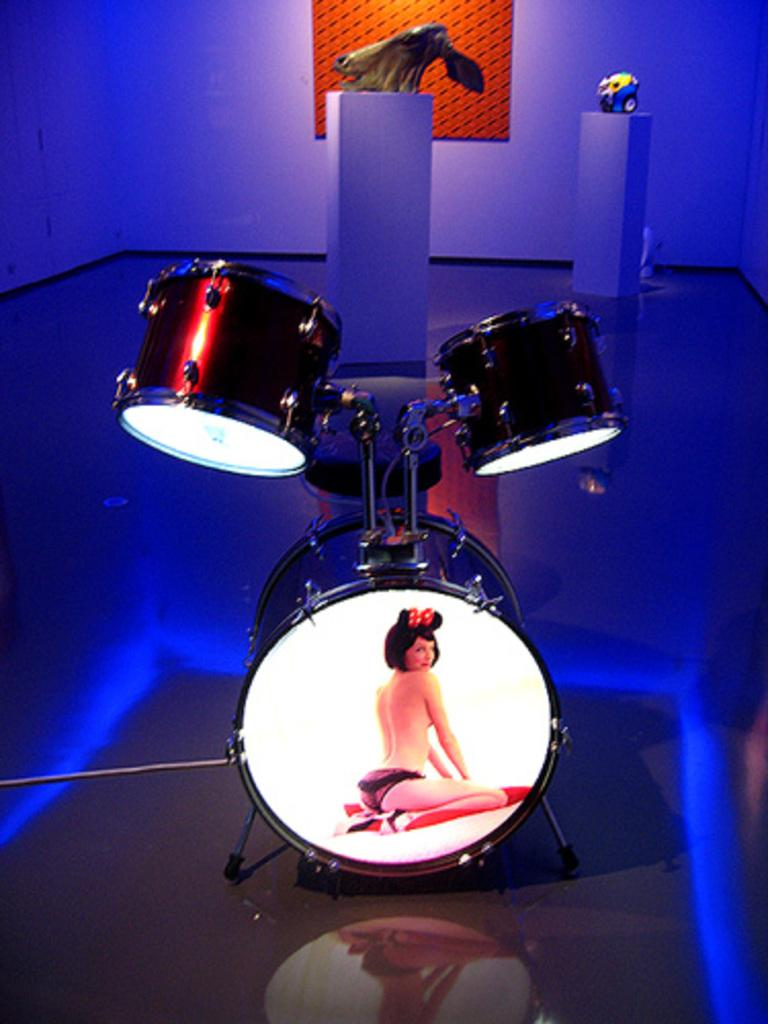What type of musical instrument is featured in the image? There are musical drums in the image. What is depicted on the musical drums? The musical drums have a picture of a woman on them. What can be seen in the background of the image? There is a wall visible in the background of the image, along with other objects. What type of lighting is present in the image? Blue color lights are present in the image. What is the price of the road visible in the image? There is no road visible in the image; it features musical drums with a picture of a woman, a wall in the background, and blue color lights. 